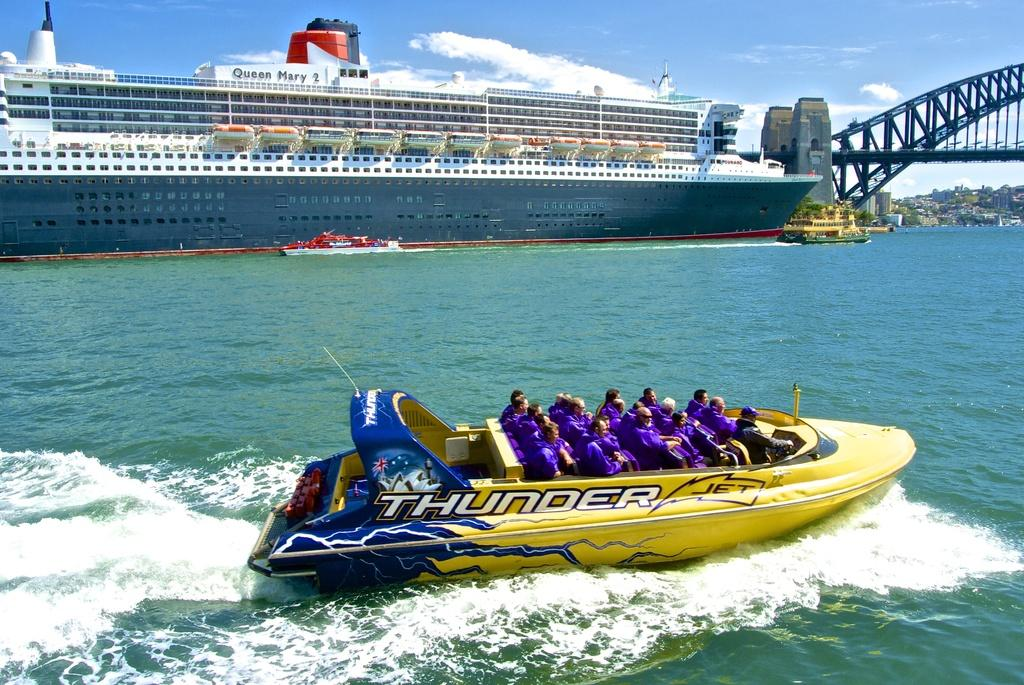<image>
Relay a brief, clear account of the picture shown. A Thunder Jet boat is speeding by a luxury cruise ship. 